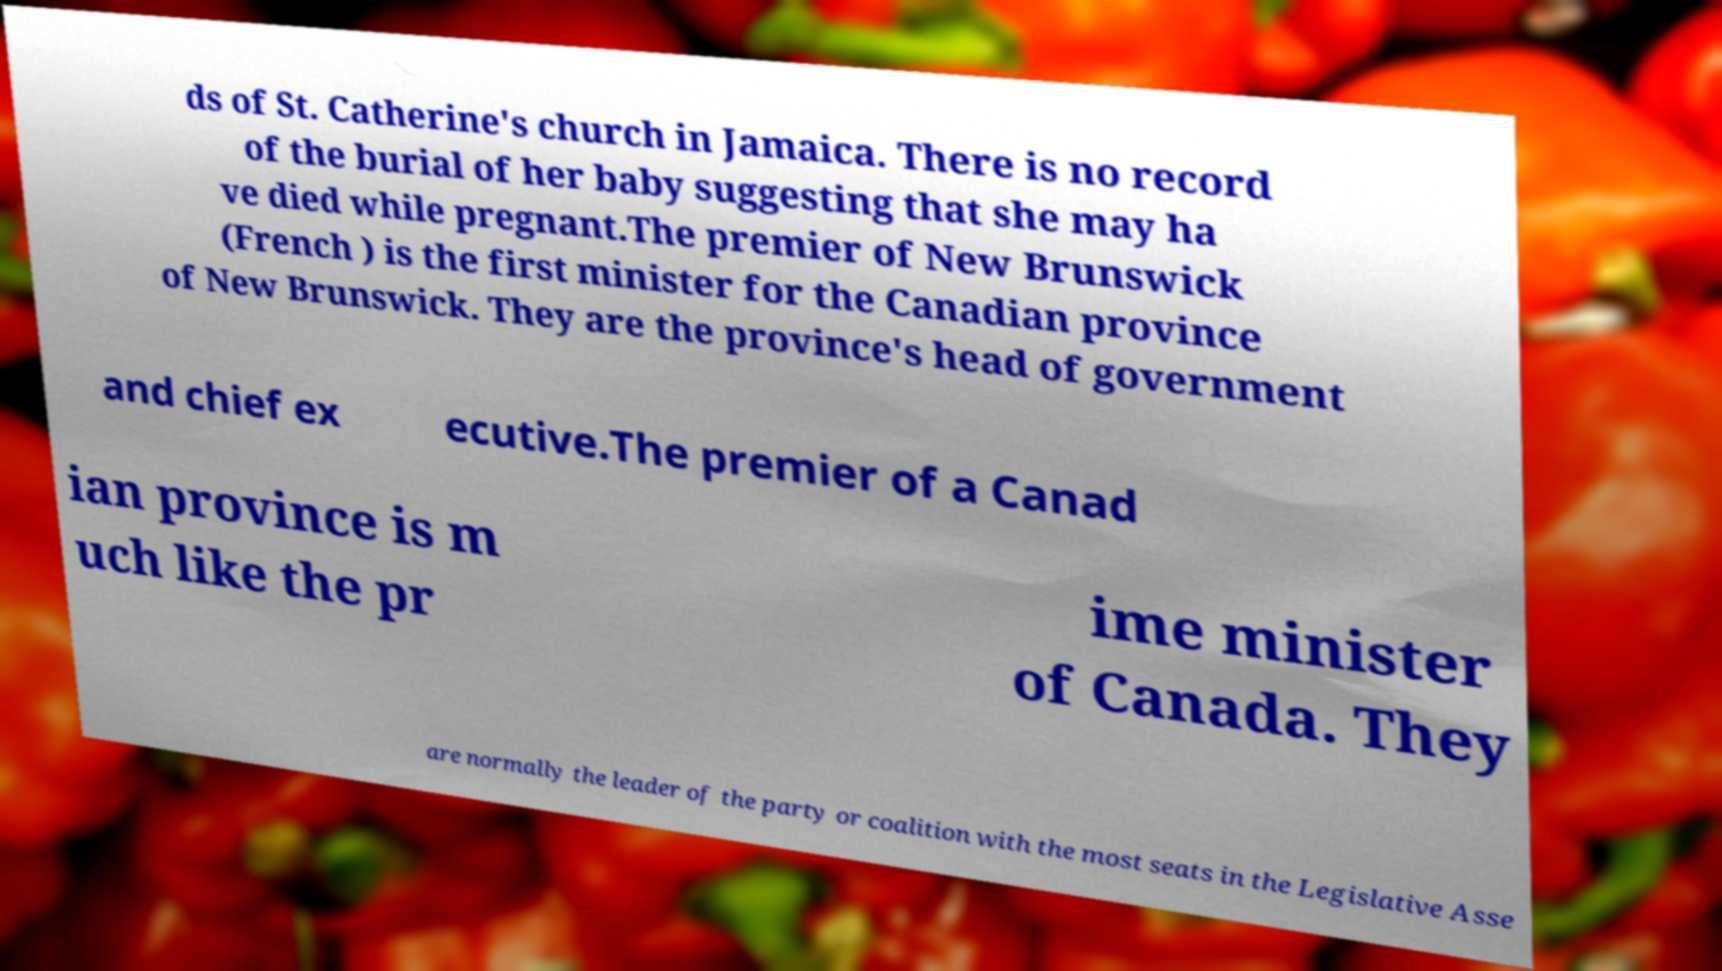For documentation purposes, I need the text within this image transcribed. Could you provide that? ds of St. Catherine's church in Jamaica. There is no record of the burial of her baby suggesting that she may ha ve died while pregnant.The premier of New Brunswick (French ) is the first minister for the Canadian province of New Brunswick. They are the province's head of government and chief ex ecutive.The premier of a Canad ian province is m uch like the pr ime minister of Canada. They are normally the leader of the party or coalition with the most seats in the Legislative Asse 